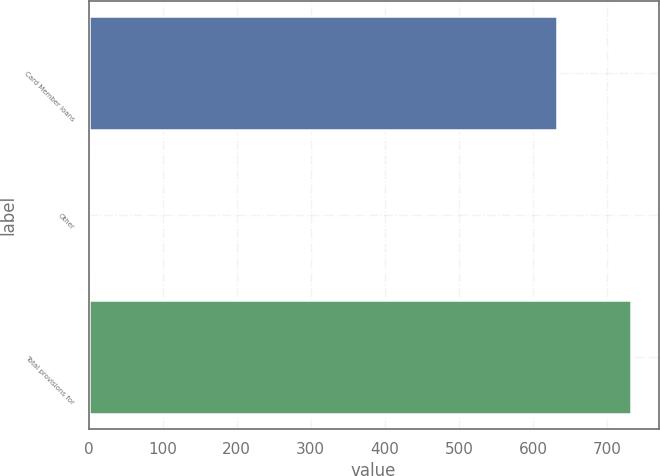<chart> <loc_0><loc_0><loc_500><loc_500><bar_chart><fcel>Card Member loans<fcel>Other<fcel>Total provisions for<nl><fcel>633<fcel>1<fcel>733<nl></chart> 